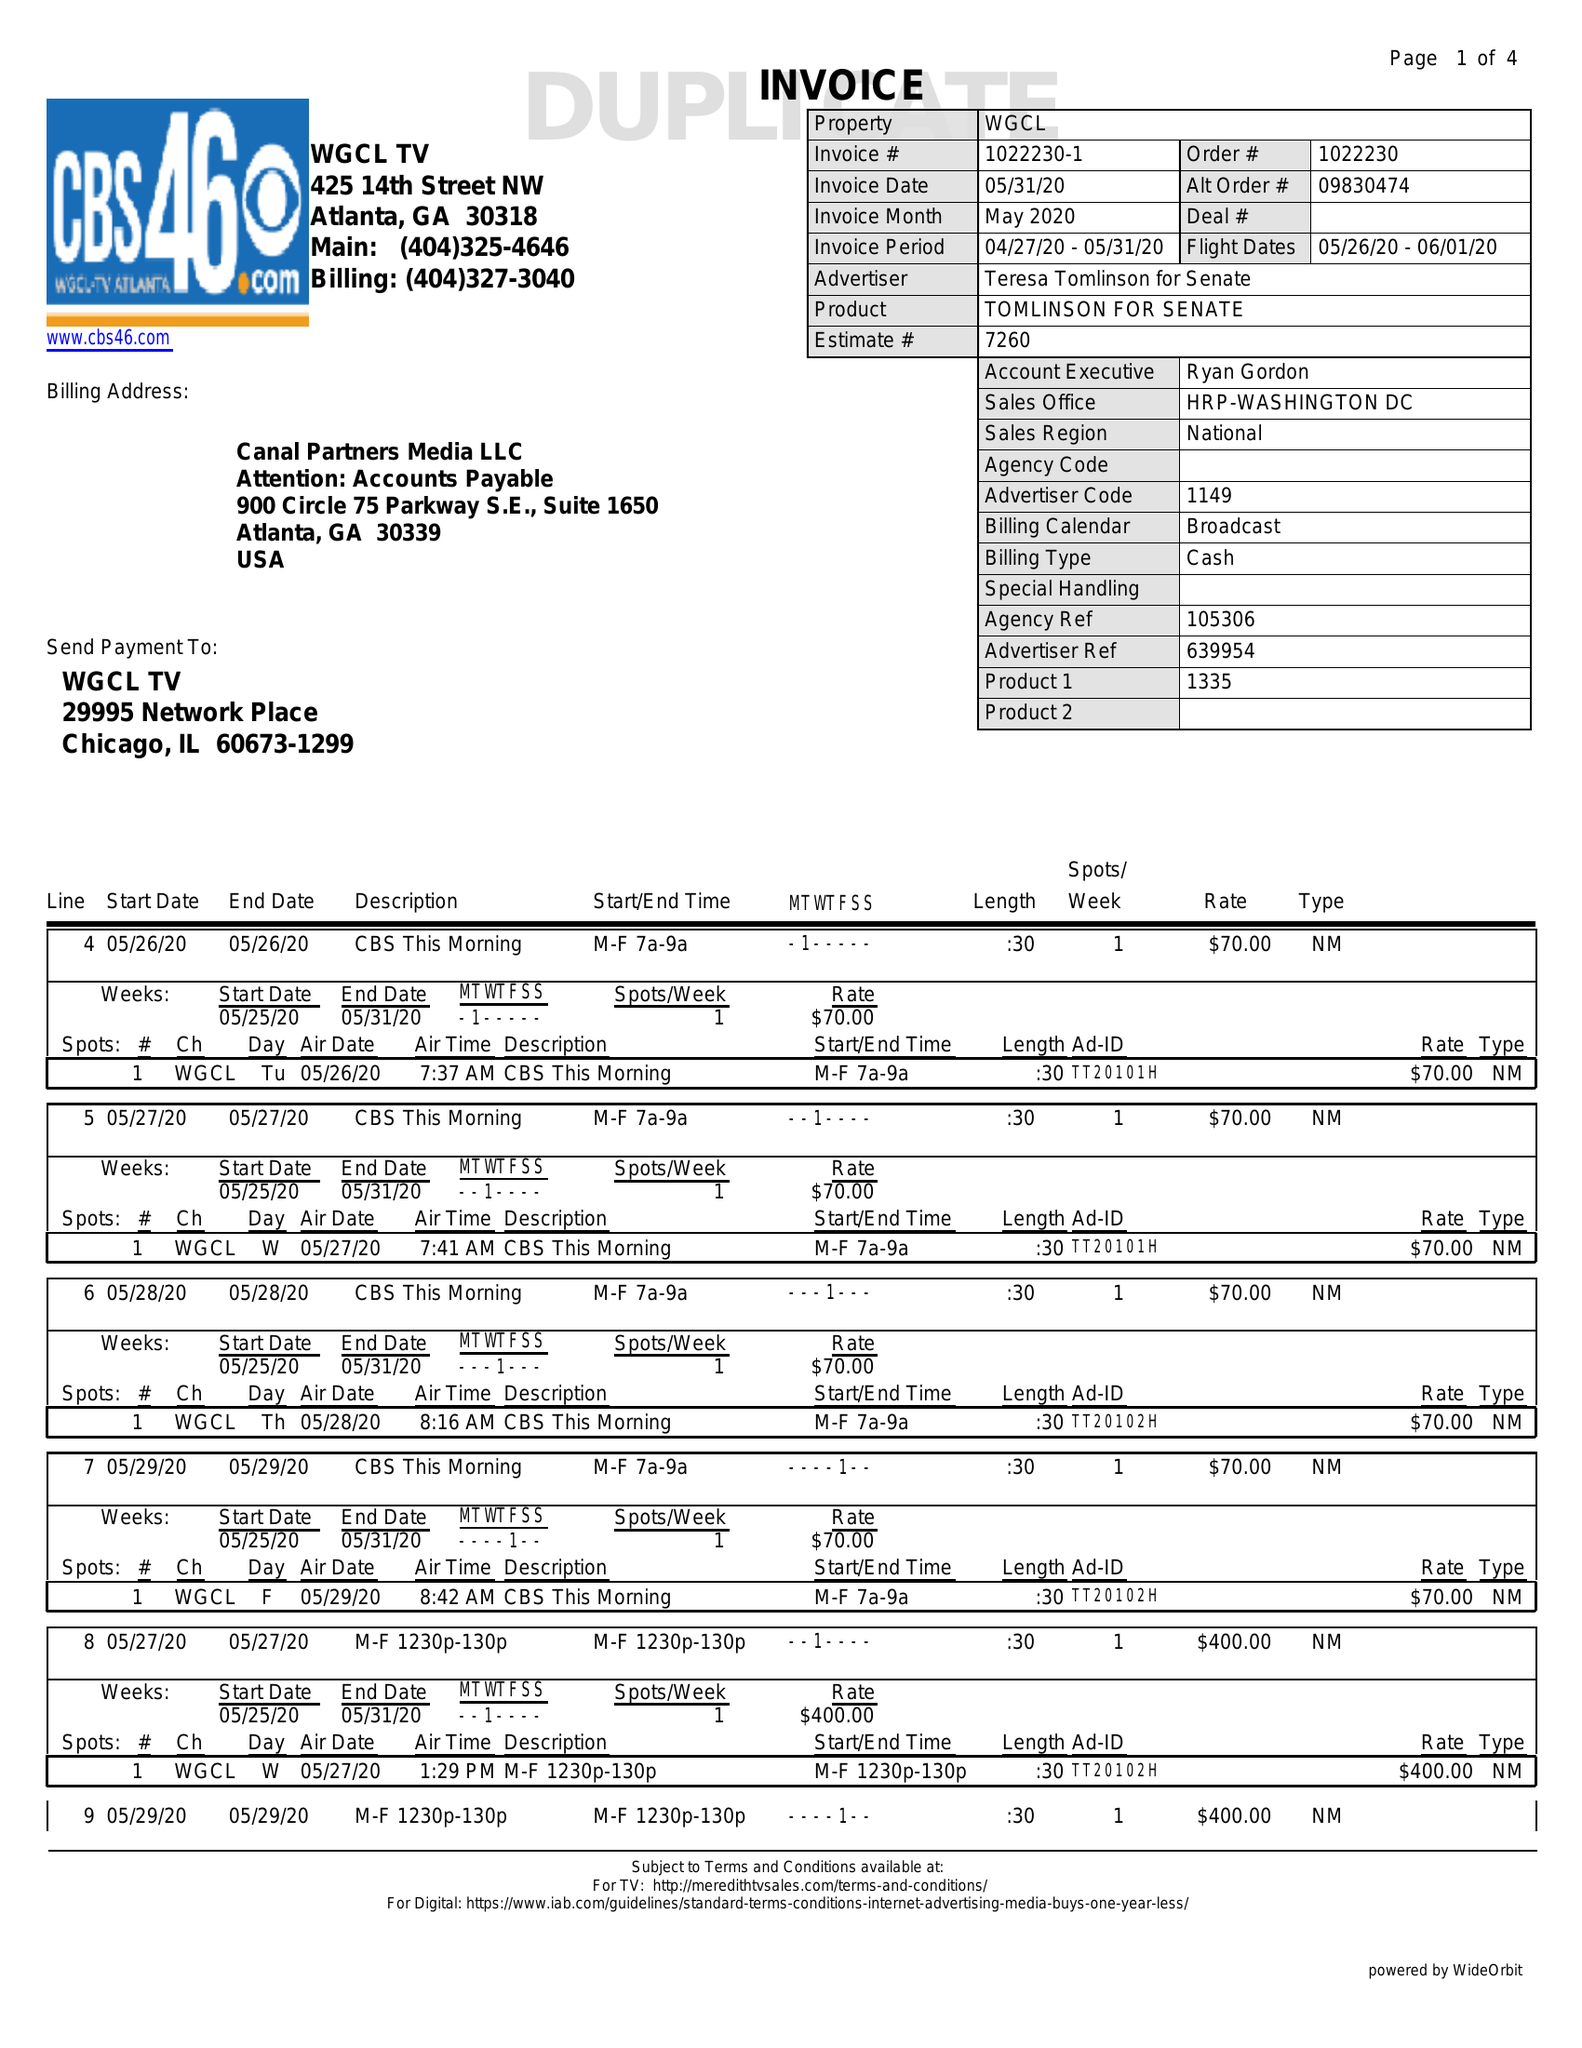What is the value for the contract_num?
Answer the question using a single word or phrase. 1022230 